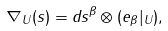<formula> <loc_0><loc_0><loc_500><loc_500>\nabla _ { U } ( s ) = d s ^ { \beta } \otimes ( e _ { \beta } | _ { U } ) ,</formula> 